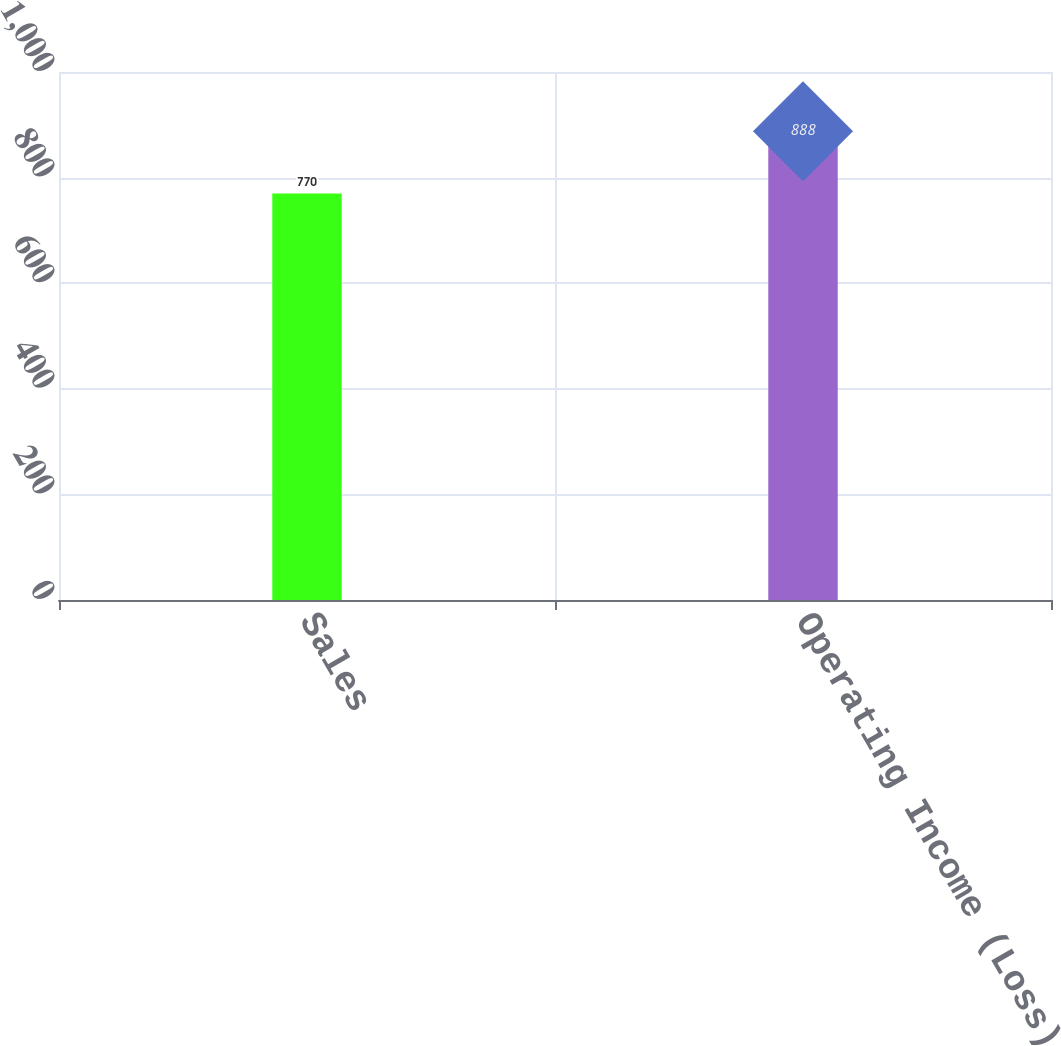Convert chart. <chart><loc_0><loc_0><loc_500><loc_500><bar_chart><fcel>Sales<fcel>Operating Income (Loss)<nl><fcel>770<fcel>888<nl></chart> 